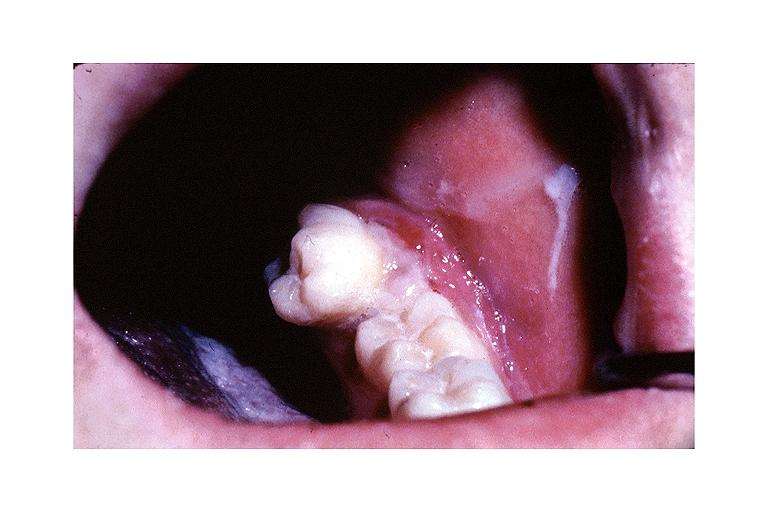what does this image show?
Answer the question using a single word or phrase. Metastatic adenocarcinoma 